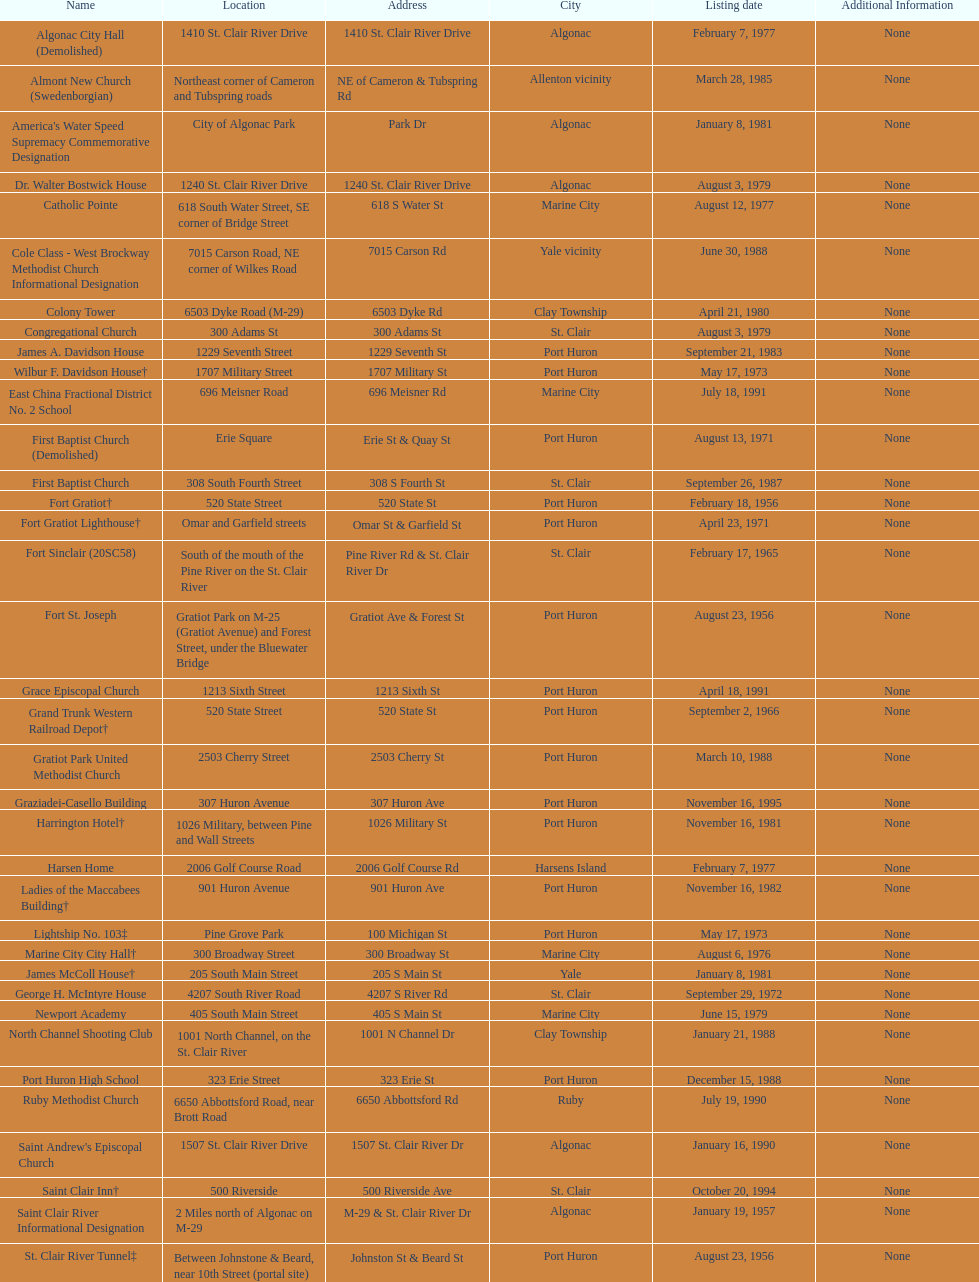What is the total number of locations in the city of algonac? 5. 